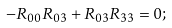<formula> <loc_0><loc_0><loc_500><loc_500>- R _ { 0 0 } R _ { 0 3 } + R _ { 0 3 } R _ { 3 3 } = 0 ;</formula> 